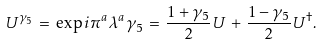<formula> <loc_0><loc_0><loc_500><loc_500>U ^ { \gamma _ { 5 } } \, = \, \exp { i \pi ^ { a } \lambda ^ { a } \gamma _ { 5 } } \, = \, \frac { 1 + \gamma _ { 5 } } { 2 } U \, + \, \frac { 1 - \gamma _ { 5 } } { 2 } U ^ { \dagger } .</formula> 